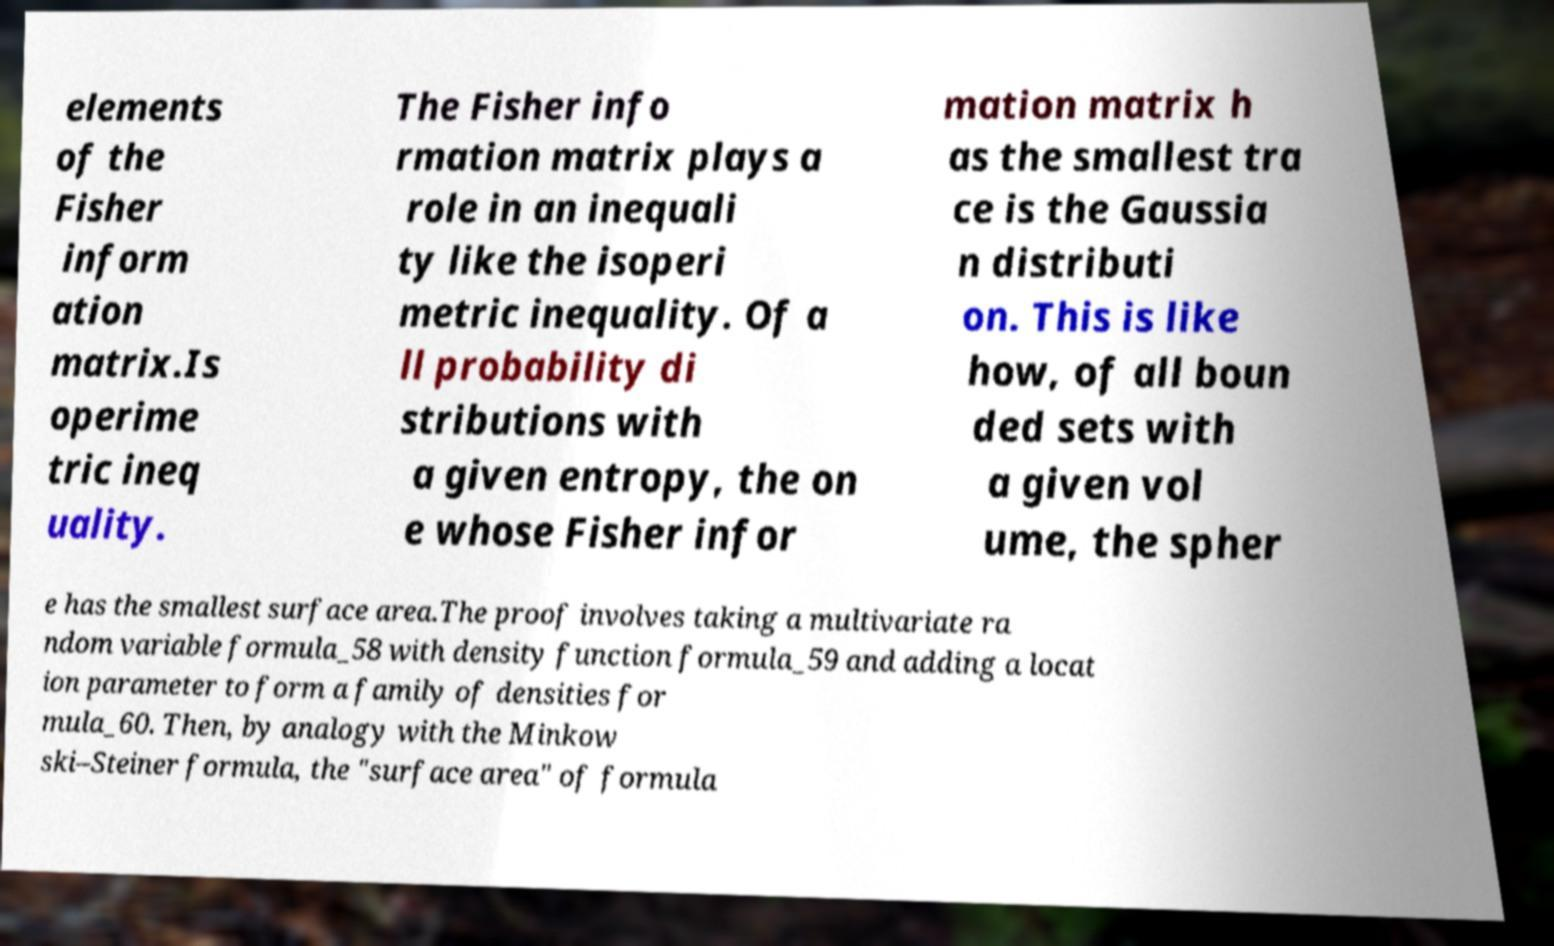For documentation purposes, I need the text within this image transcribed. Could you provide that? elements of the Fisher inform ation matrix.Is operime tric ineq uality. The Fisher info rmation matrix plays a role in an inequali ty like the isoperi metric inequality. Of a ll probability di stributions with a given entropy, the on e whose Fisher infor mation matrix h as the smallest tra ce is the Gaussia n distributi on. This is like how, of all boun ded sets with a given vol ume, the spher e has the smallest surface area.The proof involves taking a multivariate ra ndom variable formula_58 with density function formula_59 and adding a locat ion parameter to form a family of densities for mula_60. Then, by analogy with the Minkow ski–Steiner formula, the "surface area" of formula 